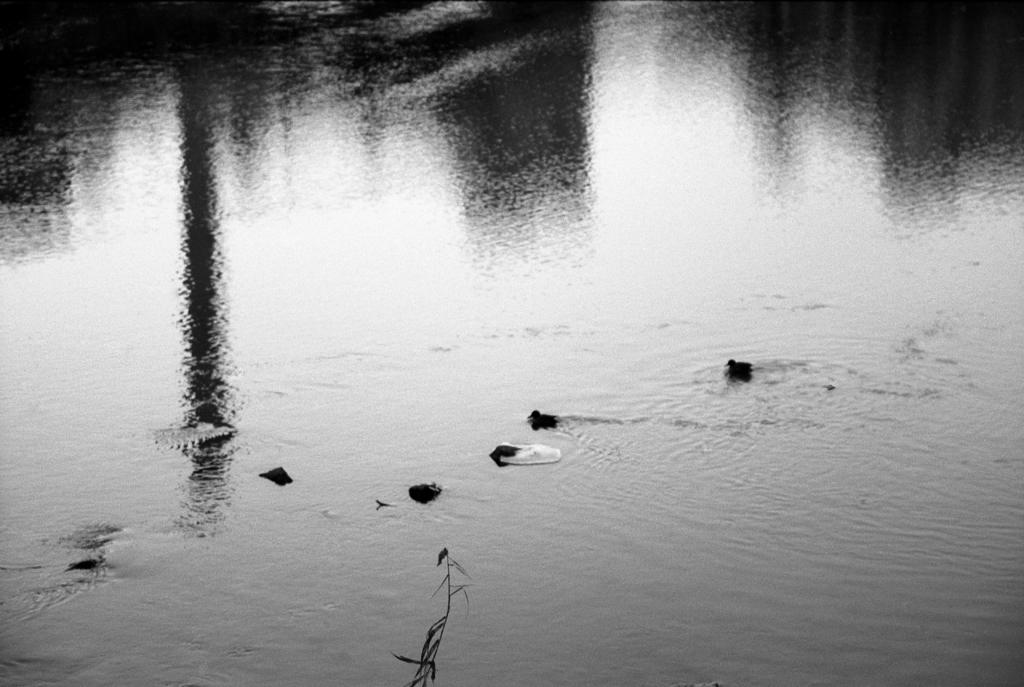What type of animals are in the water in the image? There are ducklings in the water in the image. What else can be seen in the image besides the ducklings? There is a plant visible in the image. What type of channel can be seen in the image? There is no channel present in the image; it features ducklings in the water and a plant. What reward can be seen being given to the ducklings in the image? There is no reward being given to the ducklings in the image; it simply shows them in the water. 